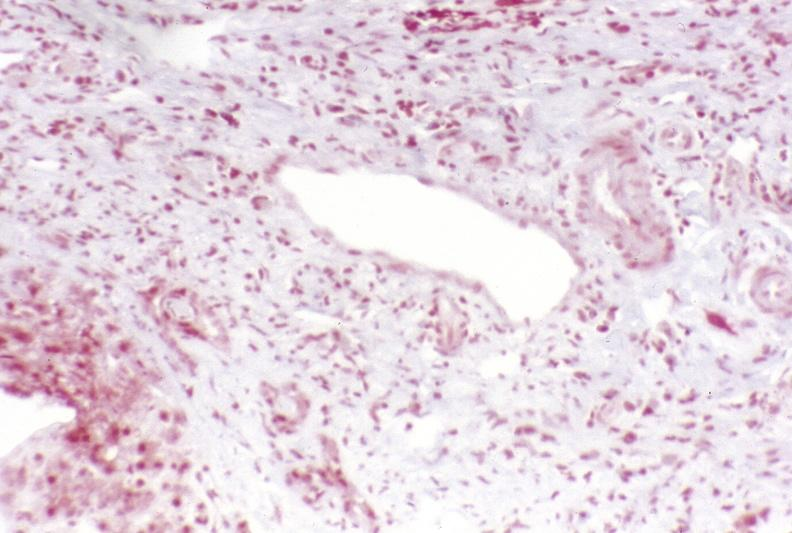does this image show primary sclerosing cholangitis?
Answer the question using a single word or phrase. Yes 